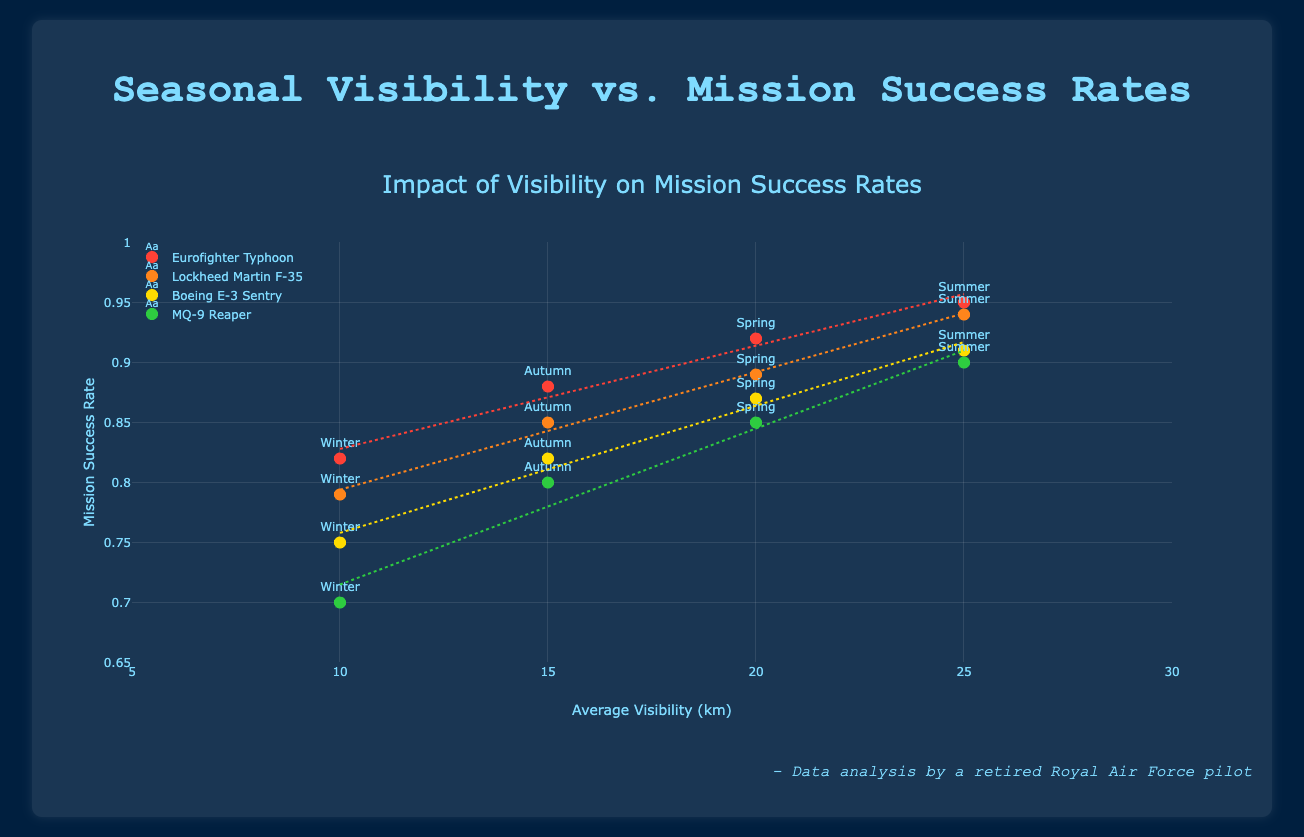What is the title of the scatter plot? The title of the scatter plot is located at the top center of the figure and it's displayed with a large font size, making it prominent and easy to read.
Answer: Impact of Visibility on Mission Success Rates What does the x-axis represent? The x-axis is labeled and the labels are visible under the axis. By reading the axis title, we can determine what the x-axis represents.
Answer: Average Visibility (km) Which aircraft has the highest mission success rate in winter? To determine this, look for the data points labeled "Winter" and check which one has the highest y-value, which represents the mission success rate.
Answer: Eurofighter Typhoon Compare the mission success rates of the Lockheed Martin F-35 and the Boeing E-3 Sentry in summer. Check the y-values of the data points labeled "Summer" for both the Lockheed Martin F-35 and the Boeing E-3 Sentry. The F-35's y-value is higher.
Answer: Lockheed Martin F-35 Which season, generally, shows the highest mission success rate for all aircraft types? To answer this, observe the trend across all aircraft types. Look at the labels of the highest points in the scatter where the y-axis, representing success rates, generally peaks.
Answer: Summer Are there any aircraft that show a consistent decrease in mission success rate from summer to winter? By examining the individual trend lines for each aircraft, look for the ones that exhibit a clear downward slope from the "Summer" data point to the "Winter" data point.
Answer: Yes, all aircraft types show a decrease What is the slope of the trend line for the Eurofighter Typhoon? Observe the trend line's angle in relation to the x-axis for the Eurofighter Typhoon. A steeper slope indicates a stronger relationship between visibility and success rate. The slope is calculated through linear regression shown in the trend lines.
Answer: Negative, indicating a decline Which aircraft has the most significant drop in mission success rate from autumn to winter? Compare the y-values between "Autumn" and "Winter" for each aircraft. A larger difference indicates a more significant drop.
Answer: Boeing E-3 Sentry How does mission success rate correlate with visibility for MQ-9 Reaper? Look at the trend line for the MQ-9 Reaper. Determine whether it ascends, descends, or remains flat as visibility increases.
Answer: Positively correlated, as the trend line slopes upwards 